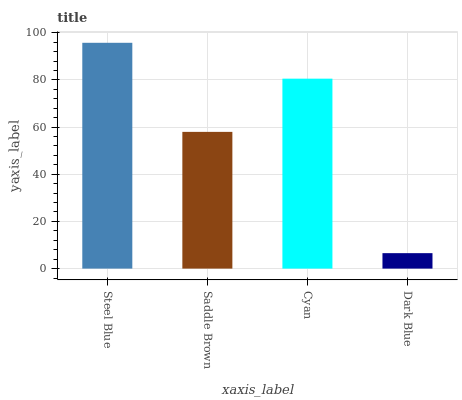Is Dark Blue the minimum?
Answer yes or no. Yes. Is Steel Blue the maximum?
Answer yes or no. Yes. Is Saddle Brown the minimum?
Answer yes or no. No. Is Saddle Brown the maximum?
Answer yes or no. No. Is Steel Blue greater than Saddle Brown?
Answer yes or no. Yes. Is Saddle Brown less than Steel Blue?
Answer yes or no. Yes. Is Saddle Brown greater than Steel Blue?
Answer yes or no. No. Is Steel Blue less than Saddle Brown?
Answer yes or no. No. Is Cyan the high median?
Answer yes or no. Yes. Is Saddle Brown the low median?
Answer yes or no. Yes. Is Saddle Brown the high median?
Answer yes or no. No. Is Cyan the low median?
Answer yes or no. No. 